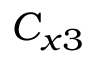Convert formula to latex. <formula><loc_0><loc_0><loc_500><loc_500>C _ { x 3 }</formula> 